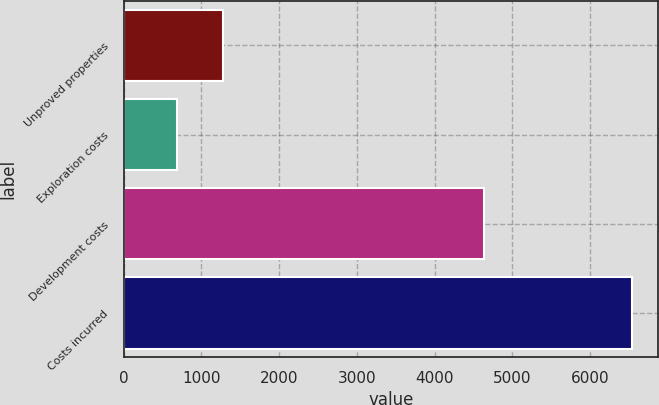Convert chart to OTSL. <chart><loc_0><loc_0><loc_500><loc_500><bar_chart><fcel>Unproved properties<fcel>Exploration costs<fcel>Development costs<fcel>Costs incurred<nl><fcel>1273.6<fcel>688<fcel>4639<fcel>6544<nl></chart> 